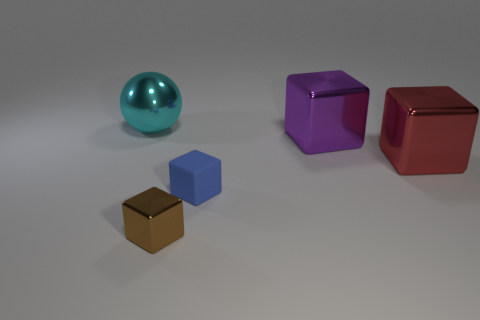Subtract all purple metallic blocks. How many blocks are left? 3 Add 2 small brown metal things. How many objects exist? 7 Subtract 1 spheres. How many spheres are left? 0 Subtract all brown blocks. How many blocks are left? 3 Subtract all cubes. How many objects are left? 1 Add 3 tiny rubber blocks. How many tiny rubber blocks are left? 4 Add 4 large purple things. How many large purple things exist? 5 Subtract 0 gray cubes. How many objects are left? 5 Subtract all yellow balls. Subtract all green cubes. How many balls are left? 1 Subtract all tiny green matte spheres. Subtract all small metallic cubes. How many objects are left? 4 